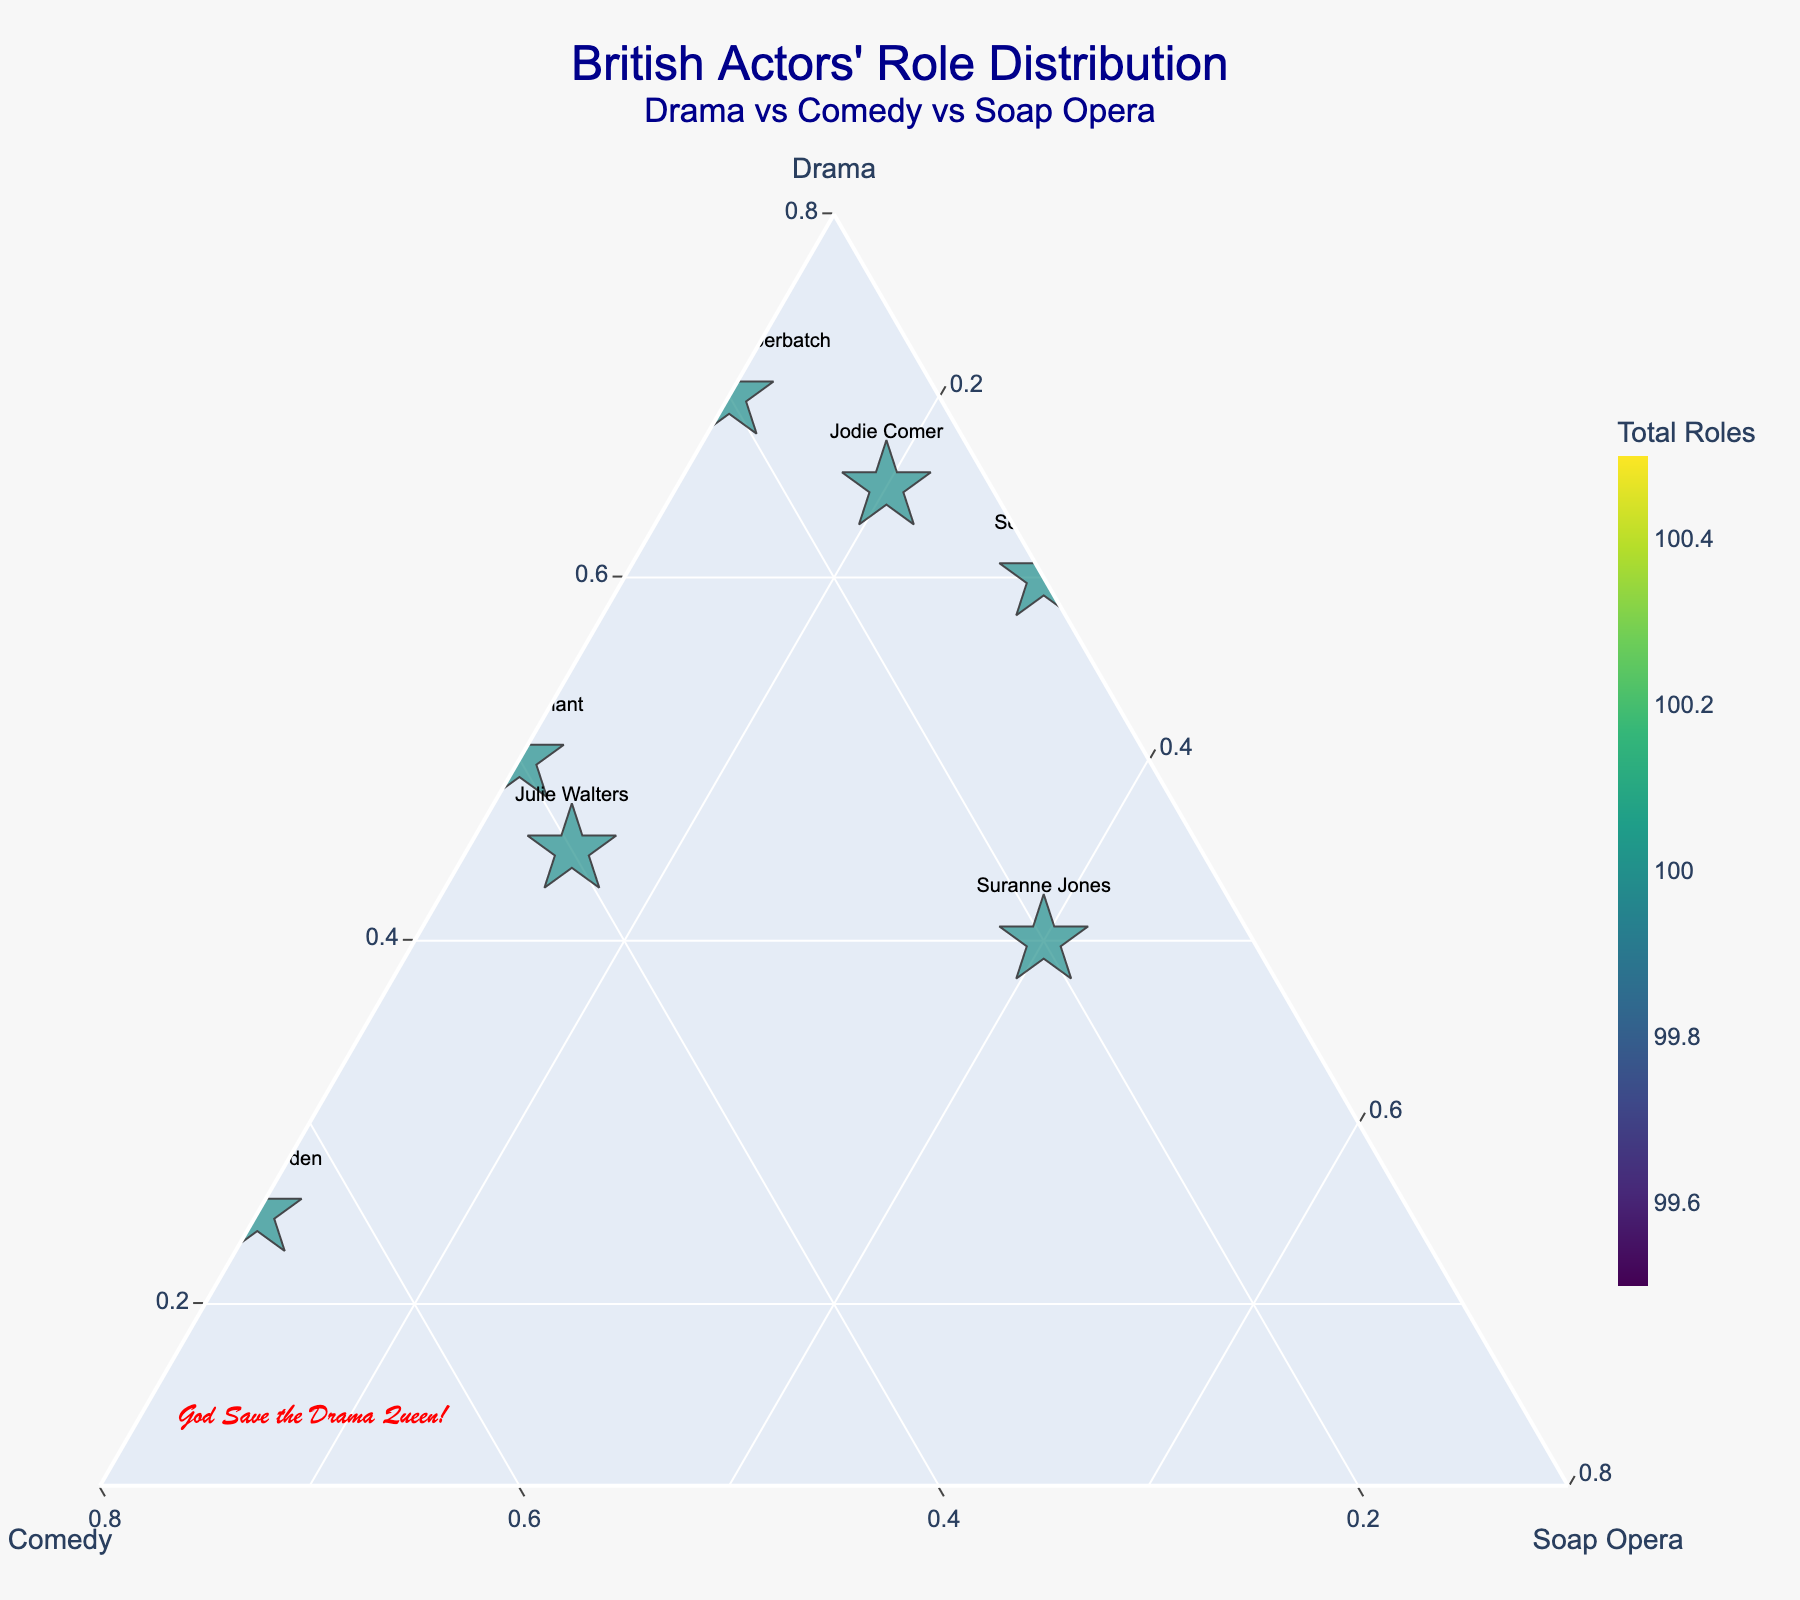Who has the highest percentage of roles in drama? Look for the actor data points nearest the Drama vertex (top corner), indicating the highest percentage. Richard Madden's point is closest with 80% Drama.
Answer: Richard Madden How many actors have a higher percentage in Soap Opera roles than in Comedy roles? Identify actors whose distance to the Soap Opera corner is shorter than to the Comedy corner. These actors are Sean Bean and Suranne Jones.
Answer: 2 Which actor has the most balanced distribution between Drama, Comedy, and Soap Opera? Look for data points closest to the center of the plot, indicating relatively equal distribution among the three genres. Julie Walters's point is near the center.
Answer: Julie Walters What genre does Ricky Gervais primarily work in? Find Ricky Gervais' data point and see which axis he is closest to. He's nearest to the Comedy axis at 85%.
Answer: Comedy Who has the lowest percentage of roles in Soap Operas and what is it? Look for the actor data points nearest the Drama-Comedy edge, which indicates minimal Soap Opera roles. Phoebe Waller-Bridge and Ricky Gervais have 0% in Soap Operas.
Answer: Phoebe Waller-Bridge and Ricky Gervais What is the combined percentage of Drama roles for Helen Mirren and Richard Madden? Helen Mirren has 75% and Richard Madden has 80% in Drama. Sum these percentages: 75 + 80 = 155%.
Answer: 155% How many actors have a total role count of 100? Locate the actors where the marker size (and hover text indicating total roles) shows 100. These actors are Sean Bean, Suranne Jones, and Richard Madden.
Answer: 3 Is there any actor who has roles in only two genres? Look for data points exactly on one of the axes, indicating zero in the opposite genre. Phoebe Waller-Bridge and Ricky Gervais are on the Drama-Comedy edge, having no Soap Opera roles.
Answer: Yes, Phoebe Waller-Bridge and Ricky Gervais Which actor has a higher percentage in Drama, David Tennant or Jodie Comer? Compare the Drama percentages. Jodie Comer has 65% in Drama, whereas David Tennant has 50%.
Answer: Jodie Comer Who appears to have the broadest range of role types among the genres given (Drama, Comedy, Soap Opera)? Look for actors whose data points are not within any single corner or edge but are spread out. Julie Walters, with Drama=45%, Comedy=40%, and Soap Opera=15%, has a broad range.
Answer: Julie Walters 